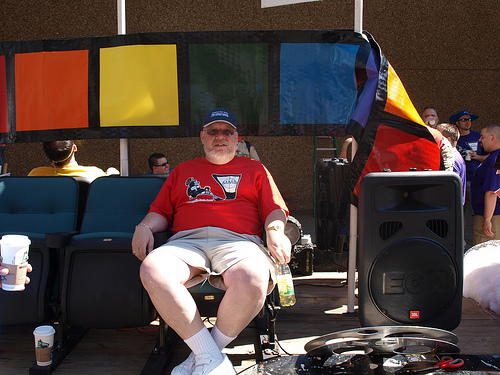<image>
Is the cup on the chair? No. The cup is not positioned on the chair. They may be near each other, but the cup is not supported by or resting on top of the chair. Is the hat behind the scissors? Yes. From this viewpoint, the hat is positioned behind the scissors, with the scissors partially or fully occluding the hat. Is there a coffee in front of the bottle? No. The coffee is not in front of the bottle. The spatial positioning shows a different relationship between these objects. 